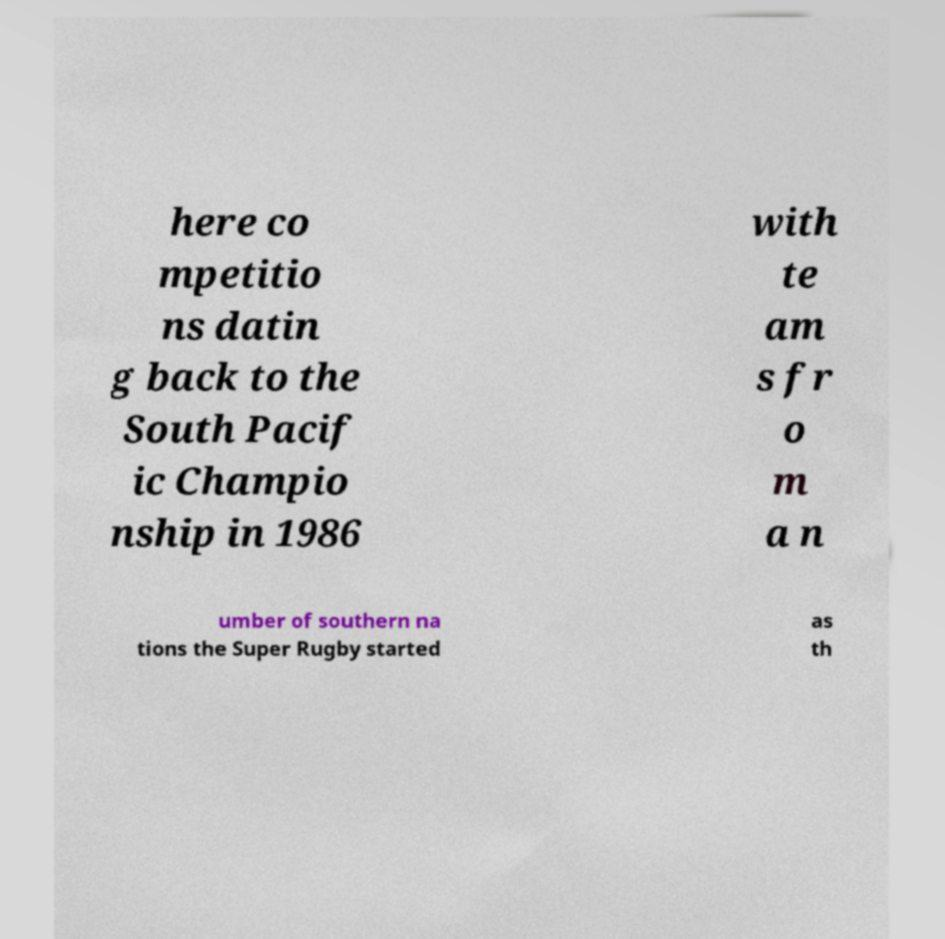There's text embedded in this image that I need extracted. Can you transcribe it verbatim? here co mpetitio ns datin g back to the South Pacif ic Champio nship in 1986 with te am s fr o m a n umber of southern na tions the Super Rugby started as th 